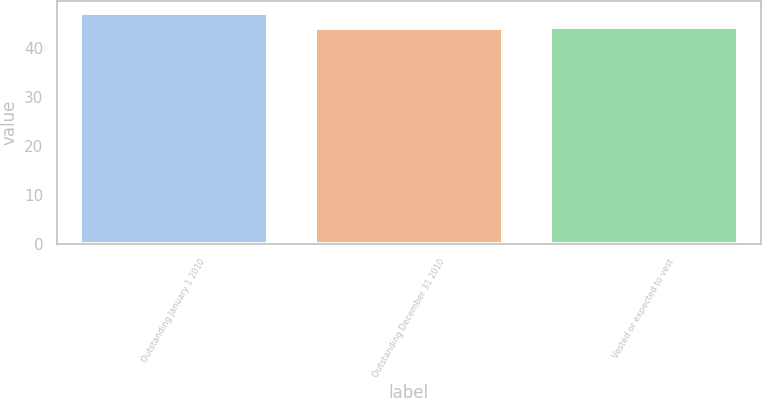Convert chart to OTSL. <chart><loc_0><loc_0><loc_500><loc_500><bar_chart><fcel>Outstanding January 1 2010<fcel>Outstanding December 31 2010<fcel>Vested or expected to vest<nl><fcel>47.15<fcel>44.03<fcel>44.34<nl></chart> 